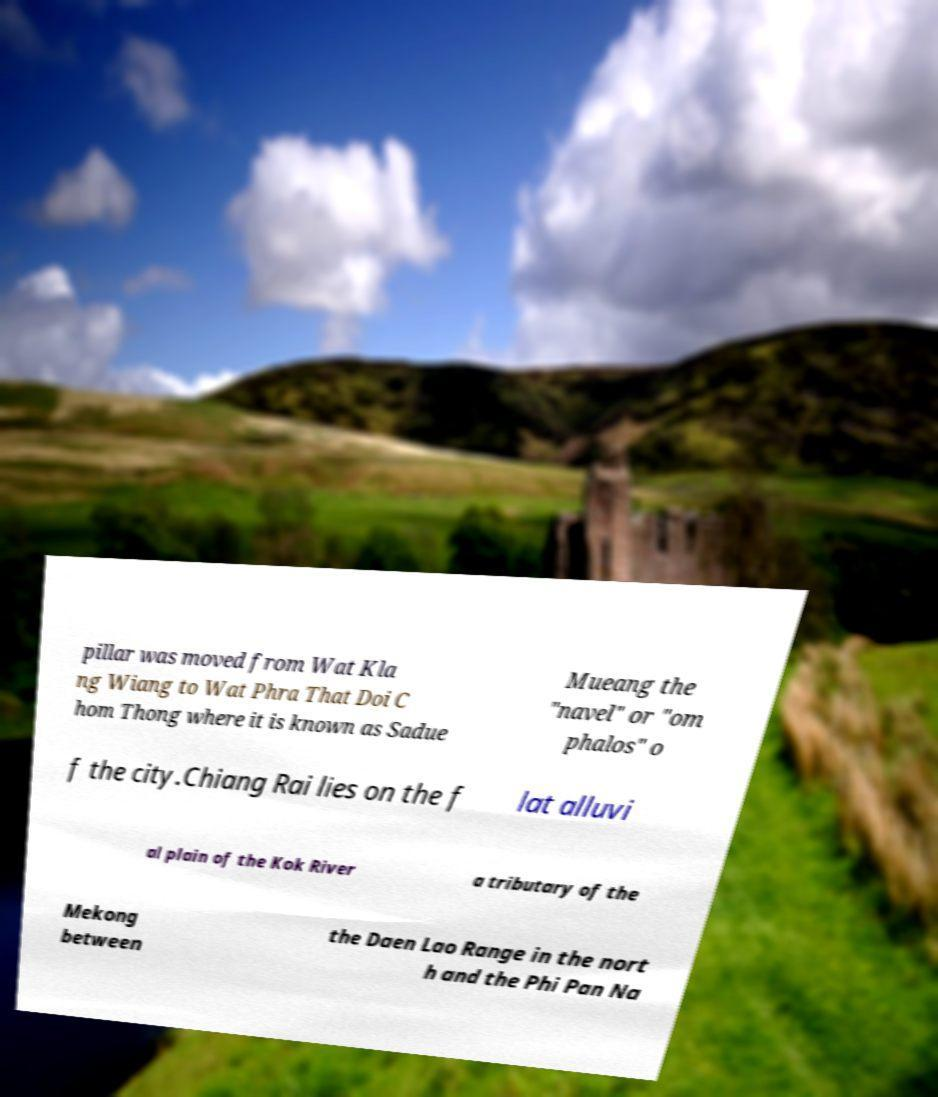Can you accurately transcribe the text from the provided image for me? pillar was moved from Wat Kla ng Wiang to Wat Phra That Doi C hom Thong where it is known as Sadue Mueang the "navel" or "om phalos" o f the city.Chiang Rai lies on the f lat alluvi al plain of the Kok River a tributary of the Mekong between the Daen Lao Range in the nort h and the Phi Pan Na 